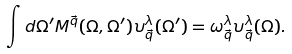Convert formula to latex. <formula><loc_0><loc_0><loc_500><loc_500>\int d \Omega ^ { \prime } M ^ { \vec { q } } ( \Omega , \Omega ^ { \prime } ) \upsilon ^ { \lambda } _ { \vec { q } } ( \Omega ^ { \prime } ) = \omega ^ { \lambda } _ { \vec { q } } \upsilon ^ { \lambda } _ { \vec { q } } ( \Omega ) .</formula> 